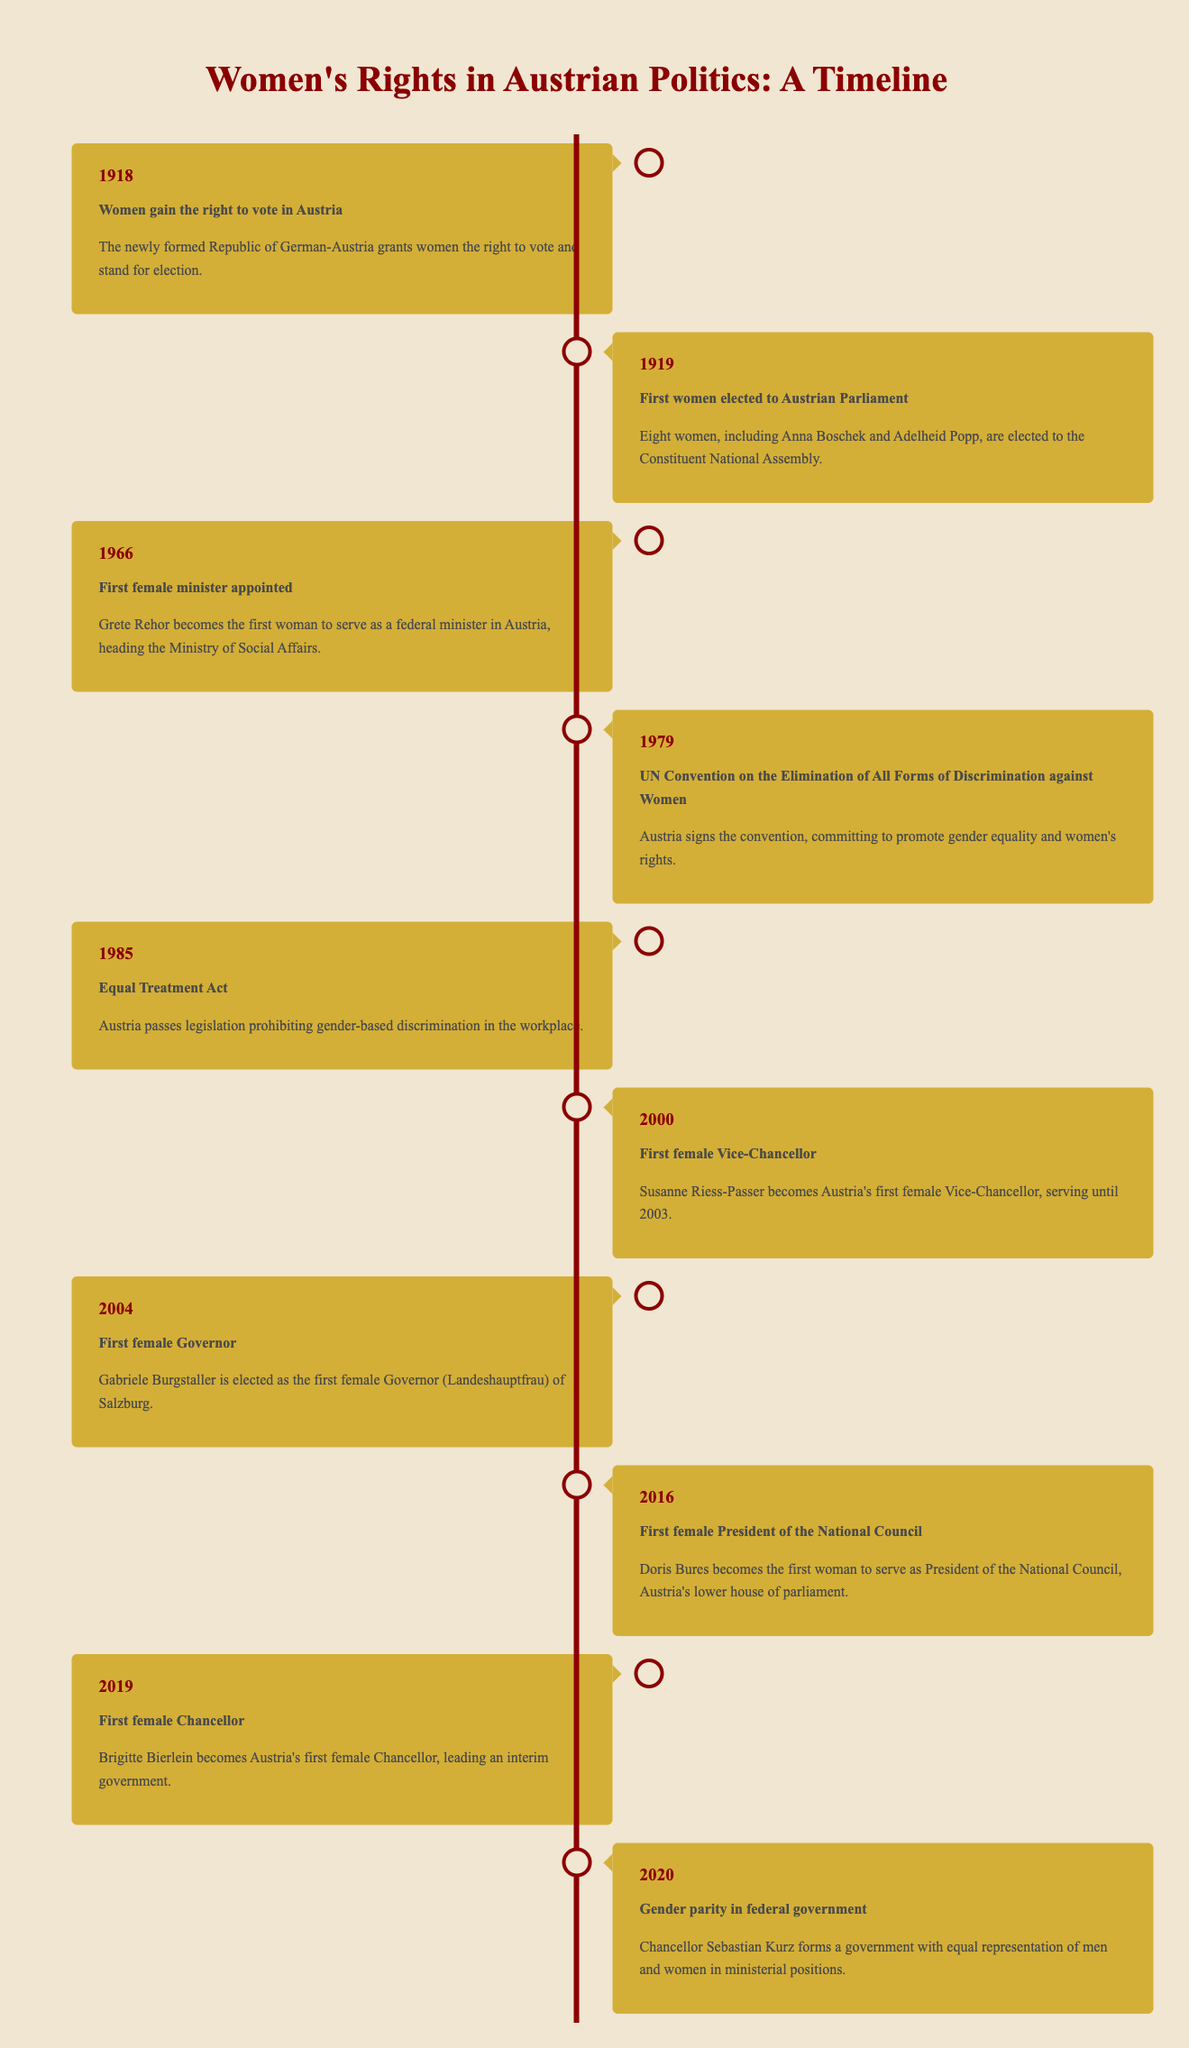What year did women in Austria gain the right to vote? The table indicates that women gained the right to vote in Austria in the year 1918.
Answer: 1918 Who was the first female minister appointed in Austria? According to the table, Grete Rehor was the first female minister appointed in Austria in 1966.
Answer: Grete Rehor How many women were elected to the Constituent National Assembly in 1919? The table states that eight women, including Anna Boschek and Adelheid Popp, were elected to the Constituent National Assembly in 1919.
Answer: Eight women What is the significance of the year 2000 in Austrian politics regarding women's representation? The year 2000 is significant because it marks the appointment of Susanne Riess-Passer as Austria's first female Vice-Chancellor.
Answer: First female Vice-Chancellor How many years passed between the appointment of the first female minister and the first female Chancellor? The first female minister was appointed in 1966, and the first female Chancellor was appointed in 2019. The difference is 2019 - 1966 = 53 years.
Answer: 53 years Was Austria's Equal Treatment Act passed before or after the UN Convention on the Elimination of All Forms of Discrimination against Women? The UN Convention was signed in 1979, while the Equal Treatment Act was passed in 1985. Therefore, the Equal Treatment Act was passed after the Convention.
Answer: After Did Austria achieve gender parity in federal government before 2020? The table indicates that gender parity in federal government was achieved in 2020, thus confirming that it was not attained before that year.
Answer: No In what context was Gabriele Burgstaller elected, and what year did it happen? Gabriele Burgstaller was elected as the first female Governor (Landeshauptfrau) of Salzburg in the year 2004.
Answer: First female Governor in 2004 In the context of this timeline, what marked a significant commitment towards promoting women's rights in 1979? The signing of the UN Convention on the Elimination of All Forms of Discrimination against Women in 1979 marked a significant commitment toward promoting women's rights in Austria.
Answer: Signing of the UN Convention 